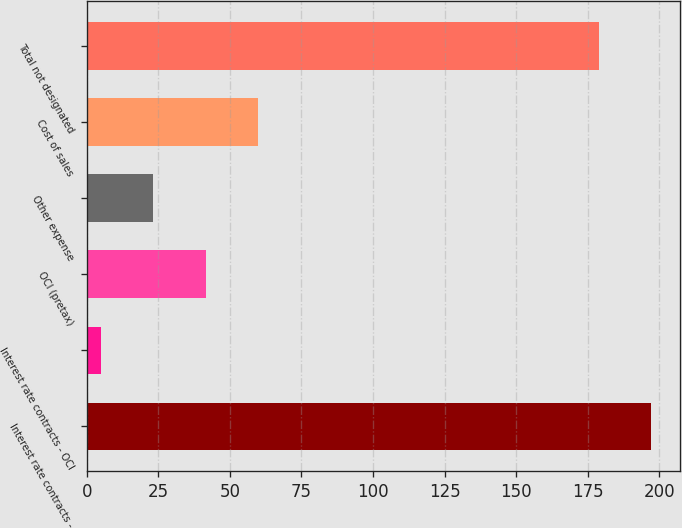Convert chart. <chart><loc_0><loc_0><loc_500><loc_500><bar_chart><fcel>Interest rate contracts -<fcel>Interest rate contracts - OCI<fcel>OCI (pretax)<fcel>Other expense<fcel>Cost of sales<fcel>Total not designated<nl><fcel>197.3<fcel>5<fcel>41.6<fcel>23.3<fcel>59.9<fcel>179<nl></chart> 